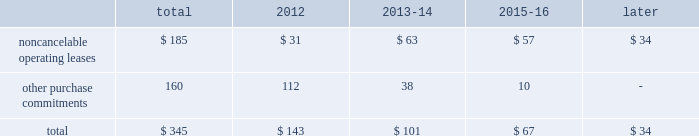2322 t .
R o w e p r i c e g r o u p a n n u a l r e p o r t 2 0 1 1 c o n t r a c t u a l o b l i g at i o n s the table presents a summary of our future obligations ( in a0millions ) under the terms of existing operating leases and other contractual cash purchase commitments at december 31 , 2011 .
Other purchase commitments include contractual amounts that will be due for the purchase of goods or services to be used in our operations and may be cancelable at earlier times than those indicated , under certain conditions that may involve termination fees .
Because these obligations are generally of a normal recurring nature , we expect that we will fund them from future cash flows from operations .
The information presented does not include operating expenses or capital expenditures that will be committed in the normal course of operations in 2012 and future years .
The information also excludes the $ 4.7 a0million of uncertain tax positions discussed in note 9 to our consolidated financial statements because it is not possible to estimate the time period in which a payment might be made to the tax authorities. .
We also have outstanding commitments to fund additional contributions to investment partnerships in which we have an existing investment totaling $ 42.5 a0million at december 31 , 2011 .
C r i t i c a l a c c o u n t i n g p o l i c i e s the preparation of financial statements often requires the selection of specific accounting methods and policies from among several acceptable alternatives .
Further , significant estimates and judgments may be required in selecting and applying those methods and policies in the recognition of the assets and liabilities in our balance sheet , the revenues and expenses in our statement of income , and the information that is contained in our significant accounting policies and notes to consolidated financial statements .
Making these estimates and judgments requires the analysis of information concerning events that may not yet be complete and of facts and circumstances that may change over time .
Accordingly , actual amounts or future results can differ materially from those estimates that we include currently in our consolidated financial statements , significant accounting policies , and notes .
We present those significant accounting policies used in the preparation of our consolidated financial statements as an integral part of those statements within this 2011 annual report .
In the following discussion , we highlight and explain further certain of those policies that are most critical to the preparation and understanding of our financial statements .
Other than temporary impairments of available-for-sale securities .
We generally classify our investment holdings in sponsored mutual funds and the debt securities held for investment by our savings bank subsidiary as available-for-sale .
At the end of each quarter , we mark the carrying amount of each investment holding to fair value and recognize an unrealized gain or loss as a component of comprehensive income within the statement of stockholders 2019 equity .
We next review each individual security position that has an unrealized loss or impairment to determine if that impairment is other than temporary .
In determining whether a mutual fund holding is other than temporarily impaired , we consider many factors , including the duration of time it has existed , the severity of the impairment , any subsequent changes in value , and our intent and ability to hold the security for a period of time sufficient for an anticipated recovery in fair value .
Subject to the other considerations noted above , with respect to duration of time , we believe a mutual fund holding with an unrealized loss that has persisted daily throughout the six months between quarter-ends is generally presumed to have an other than temporary impairment .
We may also recognize an other than temporary loss of less than six months in our statement of income if the particular circumstances of the underlying investment do not warrant our belief that a near-term recovery is possible .
An impaired debt security held by our savings bank subsidiary is considered to have an other than temporary loss that we will recognize in our statement of income if the impairment is caused by a change in credit quality that affects our ability to recover our amortized cost or if we intend to sell the security or believe that it is more likely than not that we will be required to sell the security before recovering cost .
Minor impairments of 5% ( 5 % ) or less are generally considered temporary .
Other than temporary impairments of equity method investments .
We evaluate our equity method investments , including our investment in uti , for impairment when events or changes in circumstances indicate that the carrying value of the investment exceeds its fair value , and the decline in fair value is other than temporary .
Goodwill .
We internally conduct , manage and report our operations as one investment advisory business .
We do not have distinct operating segments or components that separately constitute a business .
Accordingly , we attribute goodwill to a single reportable business segment and reporting unit 2014our investment advisory business .
We evaluate the carrying amount of goodwill in our balance sheet for possible impairment on an annual basis in the third quarter of each year using a fair value approach .
Goodwill would be considered impaired whenever our historical carrying amount exceeds the fair value of our investment advisory business .
Our annual testing has demonstrated that the fair value of our investment advisory business ( our market capitalization ) exceeds our carrying amount ( our stockholders 2019 equity ) and , therefore , no impairment exists .
Should we reach a different conclusion in the future , additional work would be performed to ascertain the amount of the non-cash impairment charge to be recognized .
We must also perform impairment testing at other times if an event or circumstance occurs indicating that it is more likely than not that an impairment has been incurred .
The maximum future impairment of goodwill that we could incur is the amount recognized in our balance sheet , $ 665.7 a0million .
Stock options .
We recognize stock option-based compensation expense in our consolidated statement of income using a fair value based method .
Fair value methods use a valuation model for shorter-term , market-traded financial instruments to theoretically value stock option grants even though they are not available for trading and are of longer duration .
The black- scholes option-pricing model that we use includes the input of certain variables that are dependent on future expectations , including the expected lives of our options from grant date to exercise date , the volatility of our underlying common shares in the market over that time period , and the rate of dividends that we will pay during that time .
Our estimates of these variables are made for the purpose of using the valuation model to determine an expense for each reporting period and are not subsequently adjusted .
Unlike most of our expenses , the resulting charge to earnings using a fair value based method is a non-cash charge that is never measured by , or adjusted based on , a cash outflow .
Provision for income taxes .
After compensation and related costs , our provision for income taxes on our earnings is our largest annual expense .
We operate in numerous states and countries through our various subsidiaries , and must allocate our income , expenses , and earnings under the various laws and regulations of each of these taxing jurisdictions .
Accordingly , our provision for income taxes represents our total estimate of the liability that we have incurred in doing business each year in all of our locations .
Annually , we file tax returns that represent our filing positions with each jurisdiction and settle our return liabilities .
Each jurisdiction has the right to audit those returns and may take different positions with respect to income and expense allocations and taxable earnings determinations .
From time to time , we may also provide for estimated liabilities associated with uncertain tax return filing positions that are subject to , or in the process of , being audited by various tax authorities .
Because the determination of our annual provision is subject to judgments and estimates , it is likely that actual results will vary from those recognized in our financial statements .
As a result , we recognize additions to , or reductions of , income tax expense during a reporting period that pertain to prior period provisions as our estimated liabilities are revised and actual tax returns and tax audits are settled .
We recognize any such prior period adjustment in the discrete quarterly period in which it is determined .
N e w ly i s s u e d b u t n o t y e t a d o p t e d a c c o u n t i n g g u i d a n c e in may 2011 , the fasb issued amended guidance clarifying how to measure and disclose fair value .
We do not believe the adoption of such amended guidance on january 1 , 2012 , will have a significant effect on our consolidated financial statements .
We have also considered all other newly issued accounting guidance that is applicable to our operations and the preparation of our consolidated statements , including that which we have not yet adopted .
We do not believe that any such guidance will have a material effect on our financial position or results of operation. .
What percentage of total other purchase commitments is made up of other purchase commitments? 
Computations: (160 / 345)
Answer: 0.46377. 